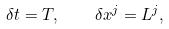Convert formula to latex. <formula><loc_0><loc_0><loc_500><loc_500>\delta t = T , \quad \delta x ^ { j } = L ^ { j } ,</formula> 